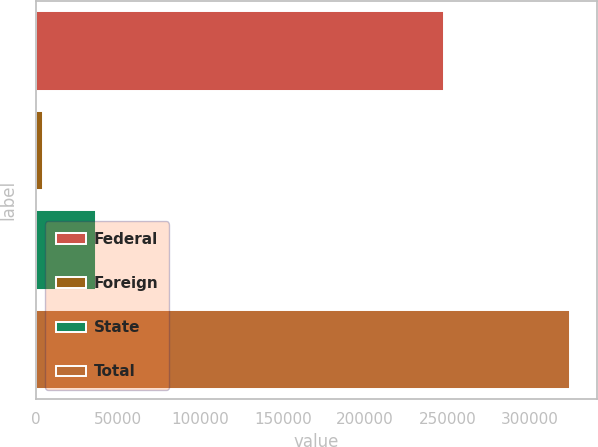<chart> <loc_0><loc_0><loc_500><loc_500><bar_chart><fcel>Federal<fcel>Foreign<fcel>State<fcel>Total<nl><fcel>248172<fcel>4167<fcel>36217.4<fcel>324671<nl></chart> 